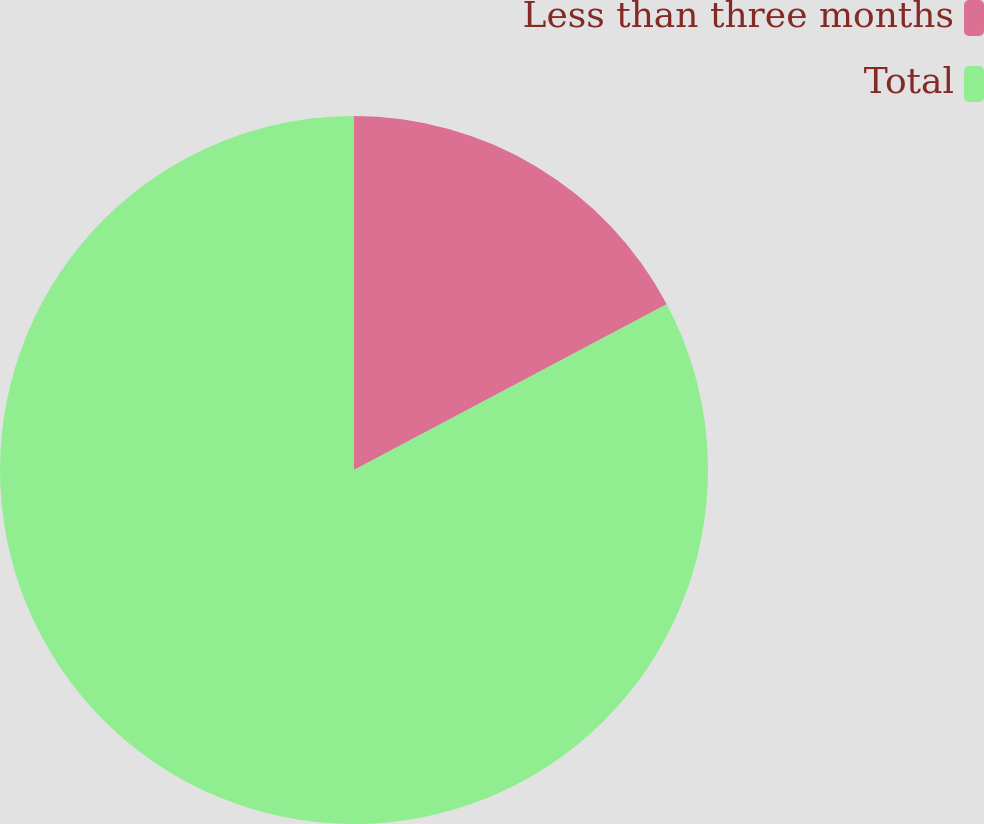<chart> <loc_0><loc_0><loc_500><loc_500><pie_chart><fcel>Less than three months<fcel>Total<nl><fcel>17.24%<fcel>82.76%<nl></chart> 